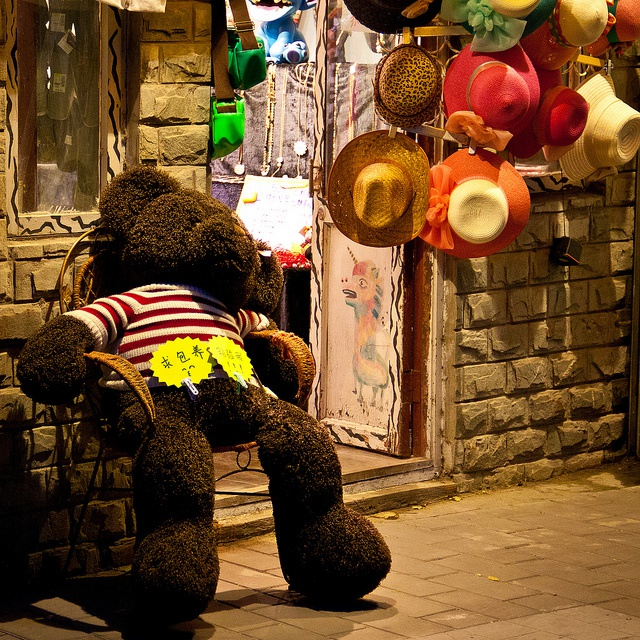Describe the objects in this image and their specific colors. I can see teddy bear in maroon, black, olive, and yellow tones, chair in maroon, black, brown, and orange tones, handbag in maroon, black, lime, and darkgreen tones, and handbag in maroon, white, khaki, red, and tan tones in this image. 